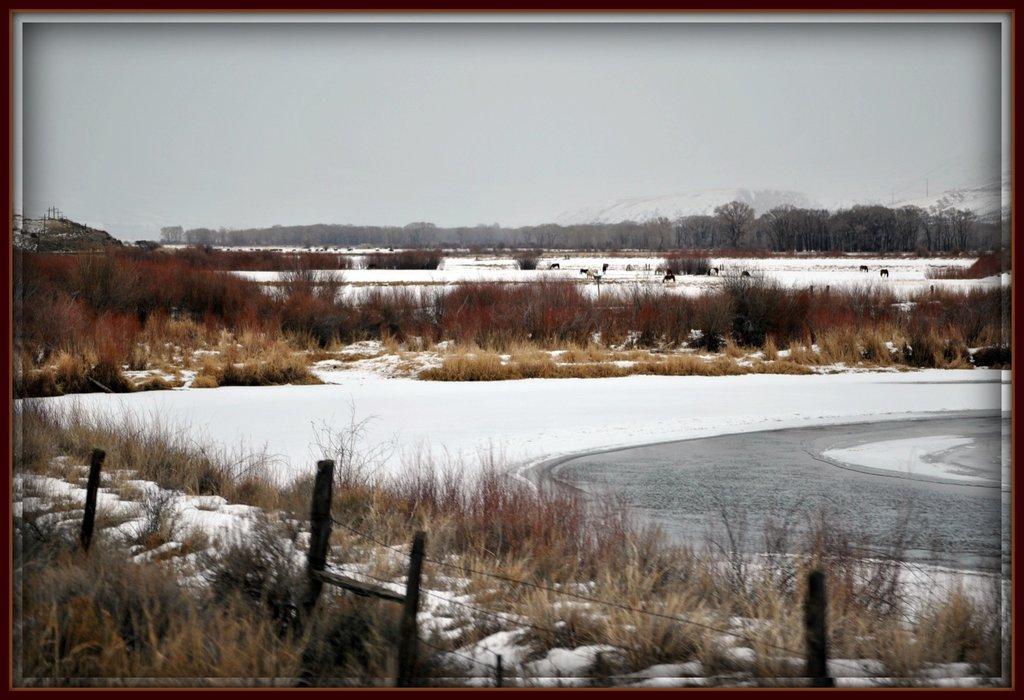Please provide a concise description of this image. At the bottom of this image, there is a fence, there is grass and snow. In the background, there are trees, water, animals, grass, mountains and there are clouds in the sky. 